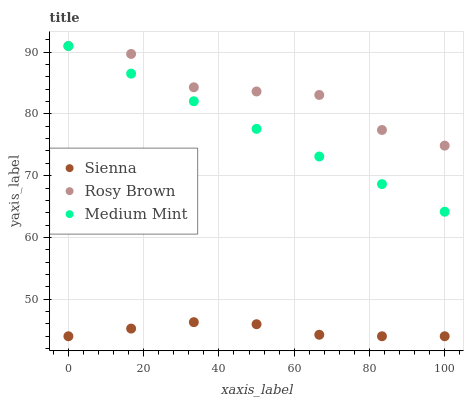Does Sienna have the minimum area under the curve?
Answer yes or no. Yes. Does Rosy Brown have the maximum area under the curve?
Answer yes or no. Yes. Does Medium Mint have the minimum area under the curve?
Answer yes or no. No. Does Medium Mint have the maximum area under the curve?
Answer yes or no. No. Is Medium Mint the smoothest?
Answer yes or no. Yes. Is Rosy Brown the roughest?
Answer yes or no. Yes. Is Rosy Brown the smoothest?
Answer yes or no. No. Is Medium Mint the roughest?
Answer yes or no. No. Does Sienna have the lowest value?
Answer yes or no. Yes. Does Medium Mint have the lowest value?
Answer yes or no. No. Does Rosy Brown have the highest value?
Answer yes or no. Yes. Is Sienna less than Medium Mint?
Answer yes or no. Yes. Is Rosy Brown greater than Sienna?
Answer yes or no. Yes. Does Rosy Brown intersect Medium Mint?
Answer yes or no. Yes. Is Rosy Brown less than Medium Mint?
Answer yes or no. No. Is Rosy Brown greater than Medium Mint?
Answer yes or no. No. Does Sienna intersect Medium Mint?
Answer yes or no. No. 